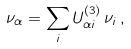Convert formula to latex. <formula><loc_0><loc_0><loc_500><loc_500>\nu _ { \alpha } = \sum _ { i } U ^ { ( 3 ) } _ { \alpha i } \, \nu _ { i } \, ,</formula> 